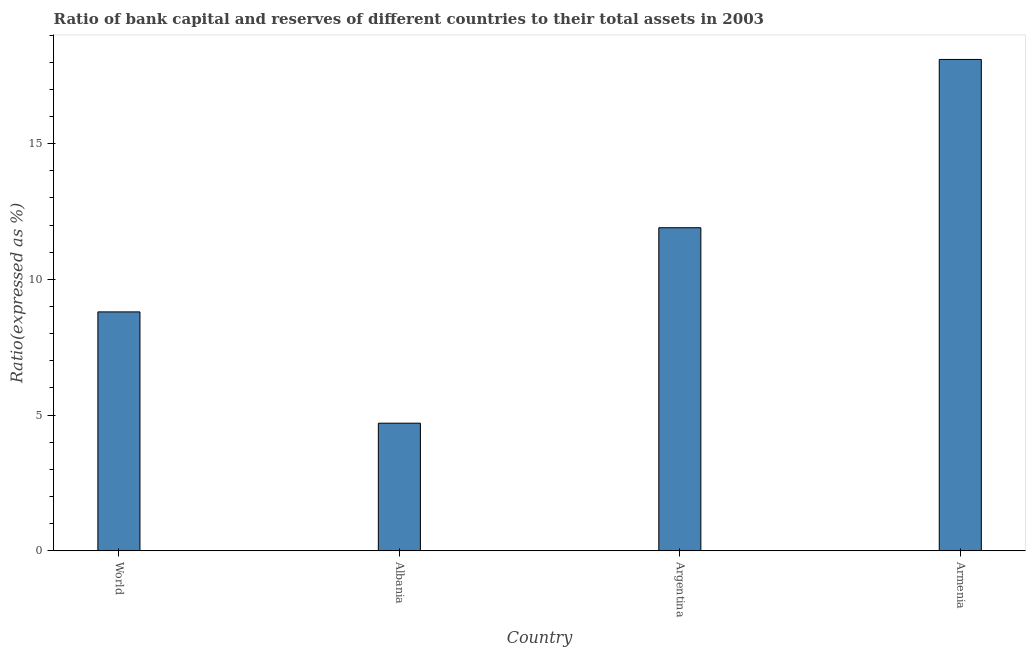Does the graph contain any zero values?
Provide a short and direct response. No. What is the title of the graph?
Give a very brief answer. Ratio of bank capital and reserves of different countries to their total assets in 2003. What is the label or title of the Y-axis?
Keep it short and to the point. Ratio(expressed as %). Across all countries, what is the maximum bank capital to assets ratio?
Ensure brevity in your answer.  18.1. Across all countries, what is the minimum bank capital to assets ratio?
Your answer should be very brief. 4.7. In which country was the bank capital to assets ratio maximum?
Provide a short and direct response. Armenia. In which country was the bank capital to assets ratio minimum?
Offer a very short reply. Albania. What is the sum of the bank capital to assets ratio?
Your response must be concise. 43.5. What is the average bank capital to assets ratio per country?
Provide a succinct answer. 10.88. What is the median bank capital to assets ratio?
Give a very brief answer. 10.35. In how many countries, is the bank capital to assets ratio greater than 1 %?
Your answer should be very brief. 4. What is the ratio of the bank capital to assets ratio in Albania to that in Armenia?
Your response must be concise. 0.26. Is the bank capital to assets ratio in Albania less than that in Argentina?
Ensure brevity in your answer.  Yes. Is the difference between the bank capital to assets ratio in Argentina and Armenia greater than the difference between any two countries?
Your answer should be very brief. No. What is the difference between the highest and the second highest bank capital to assets ratio?
Offer a terse response. 6.2. Is the sum of the bank capital to assets ratio in Albania and Argentina greater than the maximum bank capital to assets ratio across all countries?
Make the answer very short. No. How many bars are there?
Offer a very short reply. 4. Are all the bars in the graph horizontal?
Your response must be concise. No. How many countries are there in the graph?
Provide a short and direct response. 4. What is the Ratio(expressed as %) of World?
Give a very brief answer. 8.8. What is the Ratio(expressed as %) in Argentina?
Make the answer very short. 11.9. What is the difference between the Ratio(expressed as %) in Albania and Argentina?
Provide a succinct answer. -7.2. What is the difference between the Ratio(expressed as %) in Argentina and Armenia?
Your response must be concise. -6.2. What is the ratio of the Ratio(expressed as %) in World to that in Albania?
Your answer should be very brief. 1.87. What is the ratio of the Ratio(expressed as %) in World to that in Argentina?
Offer a very short reply. 0.74. What is the ratio of the Ratio(expressed as %) in World to that in Armenia?
Offer a terse response. 0.49. What is the ratio of the Ratio(expressed as %) in Albania to that in Argentina?
Your answer should be very brief. 0.4. What is the ratio of the Ratio(expressed as %) in Albania to that in Armenia?
Offer a terse response. 0.26. What is the ratio of the Ratio(expressed as %) in Argentina to that in Armenia?
Keep it short and to the point. 0.66. 